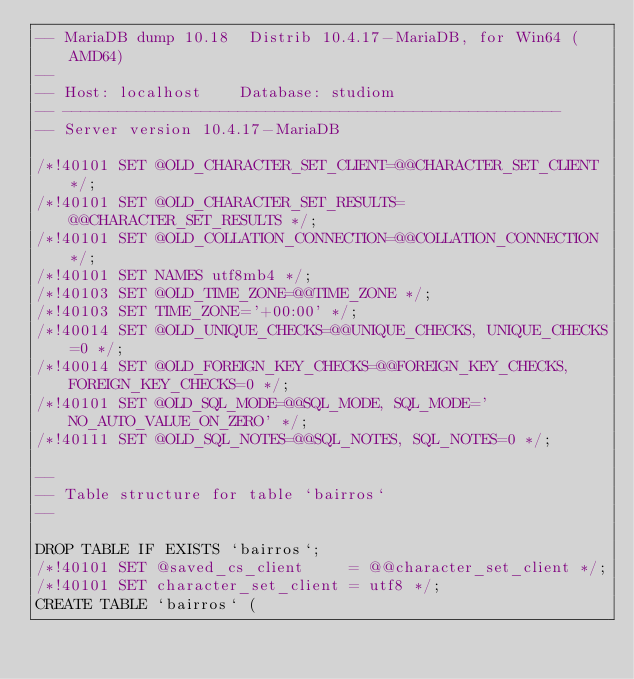Convert code to text. <code><loc_0><loc_0><loc_500><loc_500><_SQL_>-- MariaDB dump 10.18  Distrib 10.4.17-MariaDB, for Win64 (AMD64)
--
-- Host: localhost    Database: studiom
-- ------------------------------------------------------
-- Server version	10.4.17-MariaDB

/*!40101 SET @OLD_CHARACTER_SET_CLIENT=@@CHARACTER_SET_CLIENT */;
/*!40101 SET @OLD_CHARACTER_SET_RESULTS=@@CHARACTER_SET_RESULTS */;
/*!40101 SET @OLD_COLLATION_CONNECTION=@@COLLATION_CONNECTION */;
/*!40101 SET NAMES utf8mb4 */;
/*!40103 SET @OLD_TIME_ZONE=@@TIME_ZONE */;
/*!40103 SET TIME_ZONE='+00:00' */;
/*!40014 SET @OLD_UNIQUE_CHECKS=@@UNIQUE_CHECKS, UNIQUE_CHECKS=0 */;
/*!40014 SET @OLD_FOREIGN_KEY_CHECKS=@@FOREIGN_KEY_CHECKS, FOREIGN_KEY_CHECKS=0 */;
/*!40101 SET @OLD_SQL_MODE=@@SQL_MODE, SQL_MODE='NO_AUTO_VALUE_ON_ZERO' */;
/*!40111 SET @OLD_SQL_NOTES=@@SQL_NOTES, SQL_NOTES=0 */;

--
-- Table structure for table `bairros`
--

DROP TABLE IF EXISTS `bairros`;
/*!40101 SET @saved_cs_client     = @@character_set_client */;
/*!40101 SET character_set_client = utf8 */;
CREATE TABLE `bairros` (</code> 